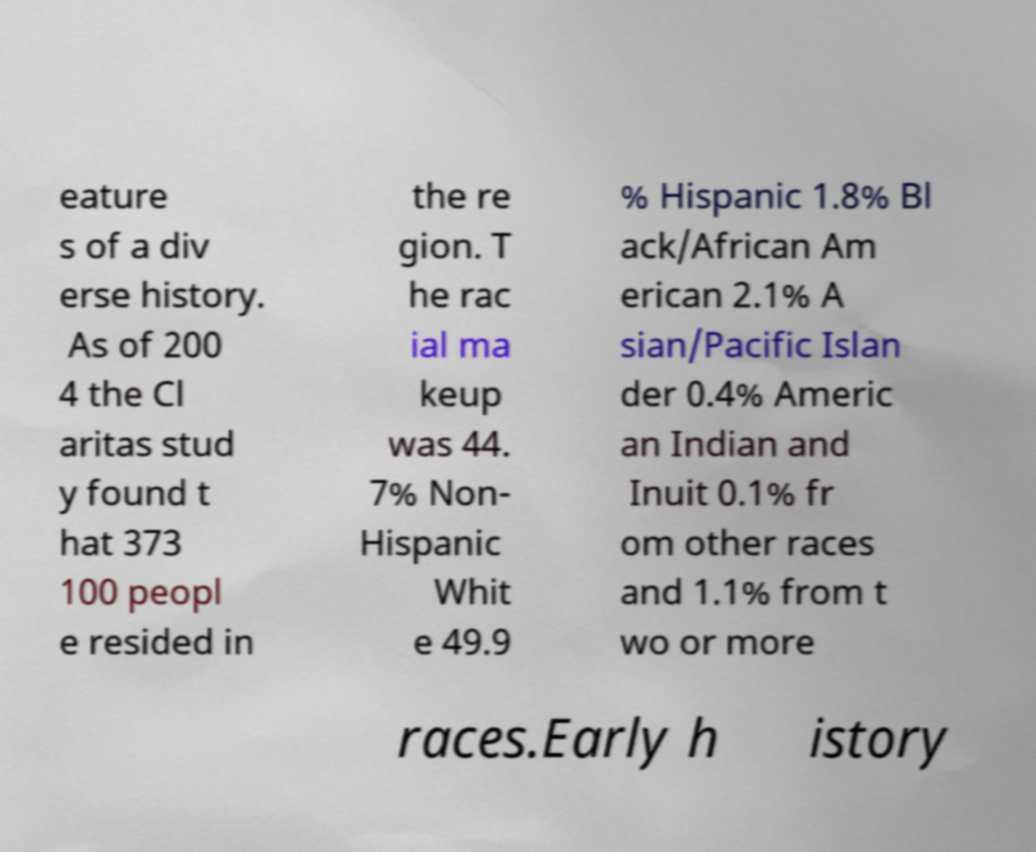There's text embedded in this image that I need extracted. Can you transcribe it verbatim? eature s of a div erse history. As of 200 4 the Cl aritas stud y found t hat 373 100 peopl e resided in the re gion. T he rac ial ma keup was 44. 7% Non- Hispanic Whit e 49.9 % Hispanic 1.8% Bl ack/African Am erican 2.1% A sian/Pacific Islan der 0.4% Americ an Indian and Inuit 0.1% fr om other races and 1.1% from t wo or more races.Early h istory 